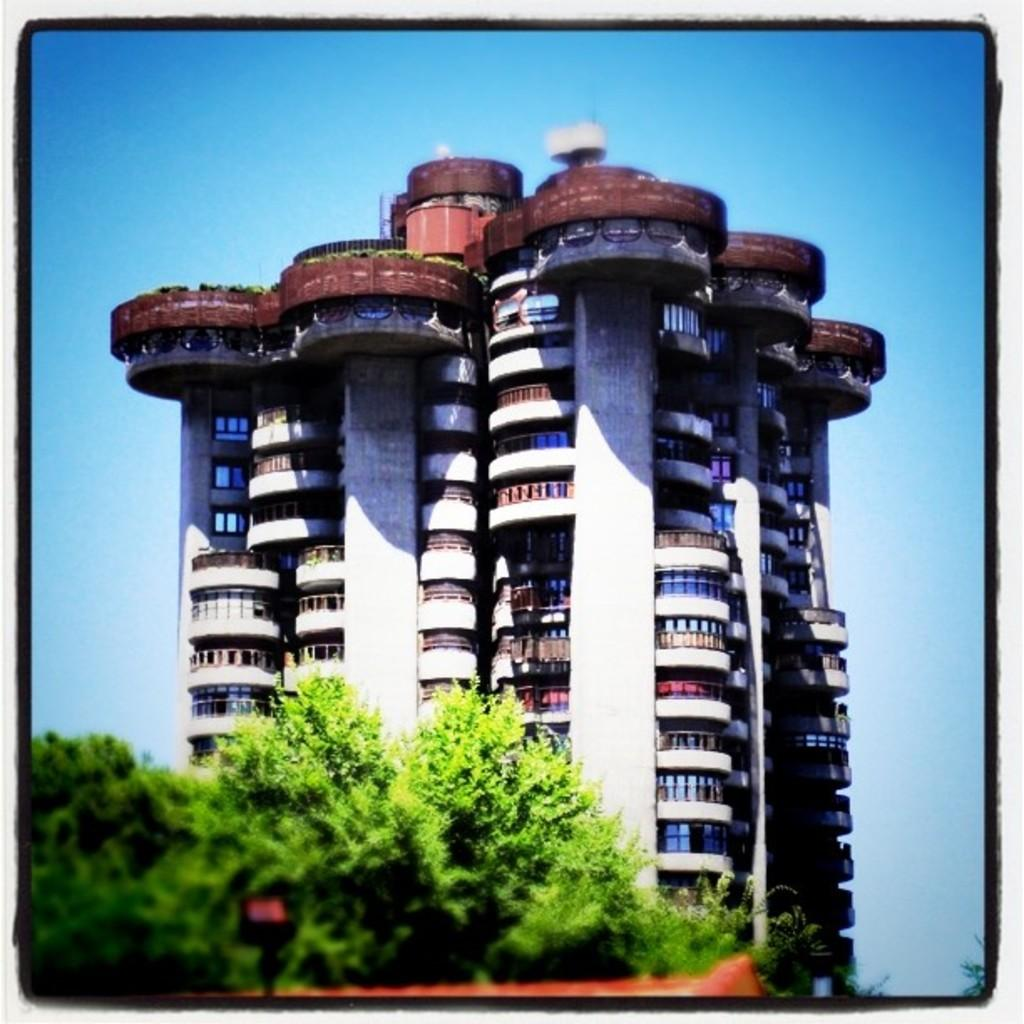What is the main structure in the image? There is a huge building in the image. What is located in front of the building? There are trees in front of the building. What can be seen in the background of the image? The sky is visible in the background of the image. What type of wall can be seen surrounding the building in the image? There is no wall surrounding the building in the image. What road leads to the building in the image? There is no road visible in the image. 